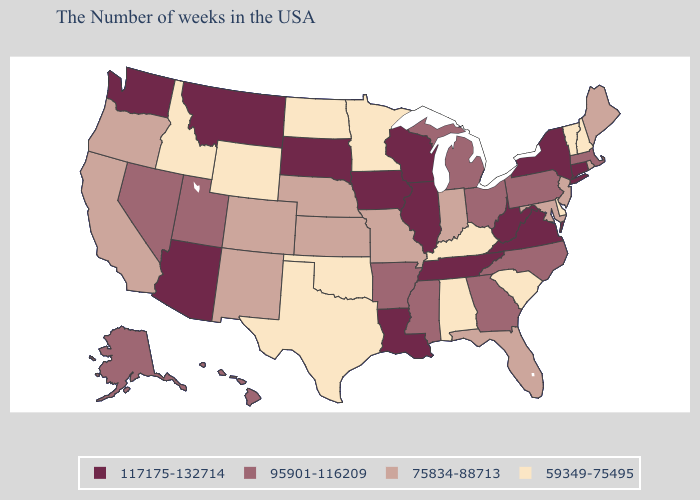Is the legend a continuous bar?
Write a very short answer. No. Name the states that have a value in the range 95901-116209?
Quick response, please. Massachusetts, Pennsylvania, North Carolina, Ohio, Georgia, Michigan, Mississippi, Arkansas, Utah, Nevada, Alaska, Hawaii. Does Iowa have the highest value in the USA?
Concise answer only. Yes. Does the first symbol in the legend represent the smallest category?
Write a very short answer. No. Name the states that have a value in the range 59349-75495?
Write a very short answer. New Hampshire, Vermont, Delaware, South Carolina, Kentucky, Alabama, Minnesota, Oklahoma, Texas, North Dakota, Wyoming, Idaho. Among the states that border North Carolina , does Tennessee have the lowest value?
Concise answer only. No. Name the states that have a value in the range 59349-75495?
Quick response, please. New Hampshire, Vermont, Delaware, South Carolina, Kentucky, Alabama, Minnesota, Oklahoma, Texas, North Dakota, Wyoming, Idaho. What is the lowest value in the USA?
Concise answer only. 59349-75495. Does South Dakota have the highest value in the MidWest?
Quick response, please. Yes. Does the first symbol in the legend represent the smallest category?
Short answer required. No. What is the value of New Jersey?
Quick response, please. 75834-88713. What is the lowest value in the USA?
Write a very short answer. 59349-75495. What is the highest value in the Northeast ?
Short answer required. 117175-132714. Does North Carolina have the lowest value in the USA?
Short answer required. No. 